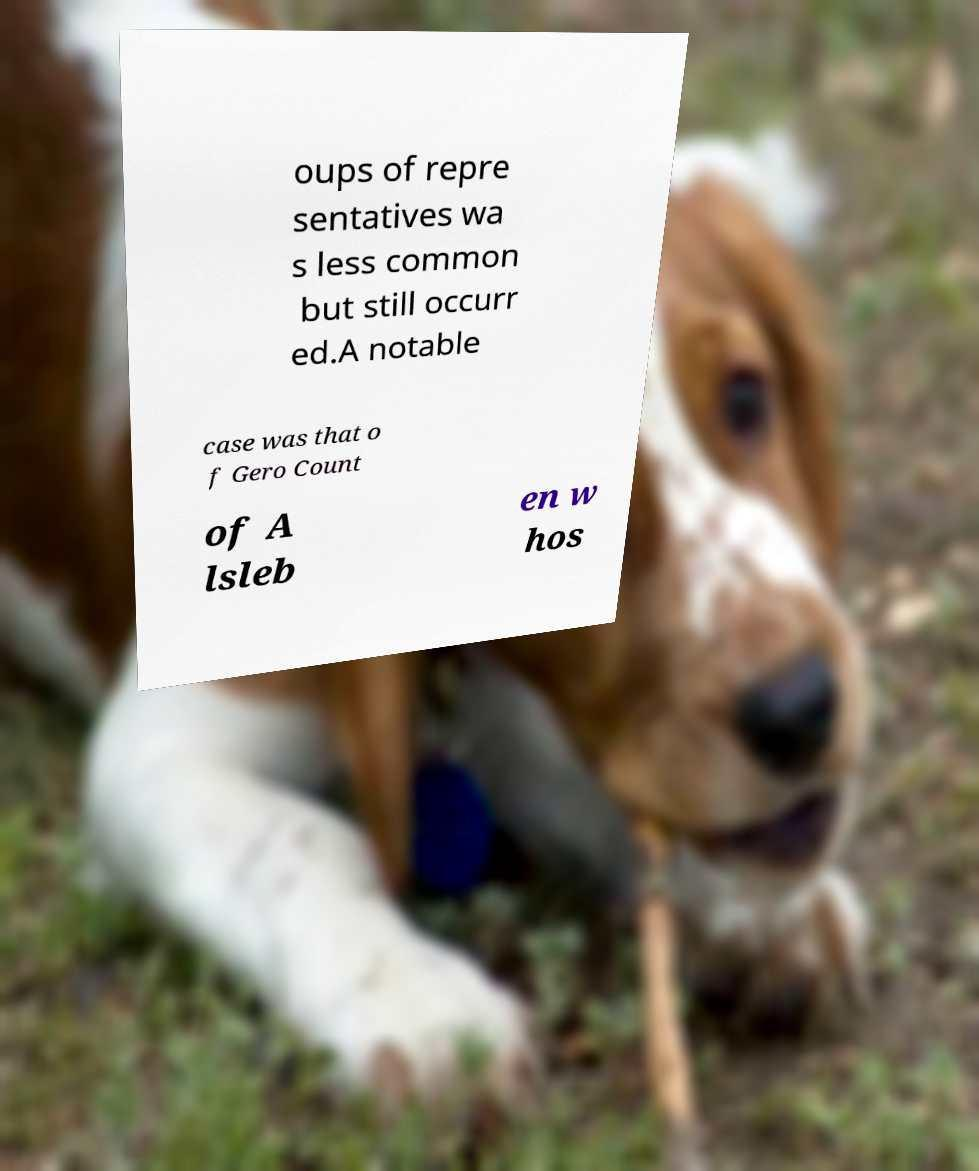Could you assist in decoding the text presented in this image and type it out clearly? oups of repre sentatives wa s less common but still occurr ed.A notable case was that o f Gero Count of A lsleb en w hos 